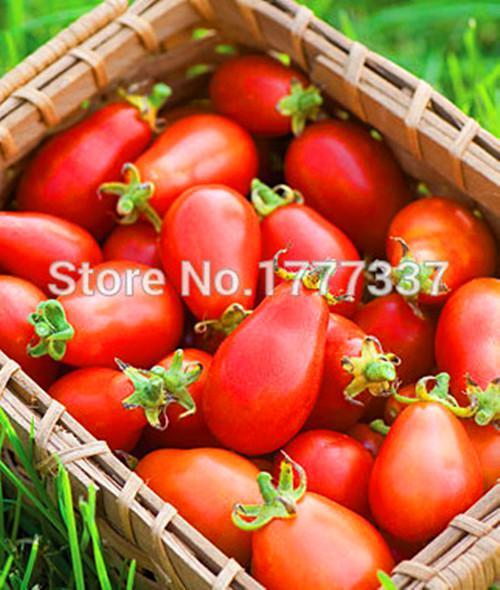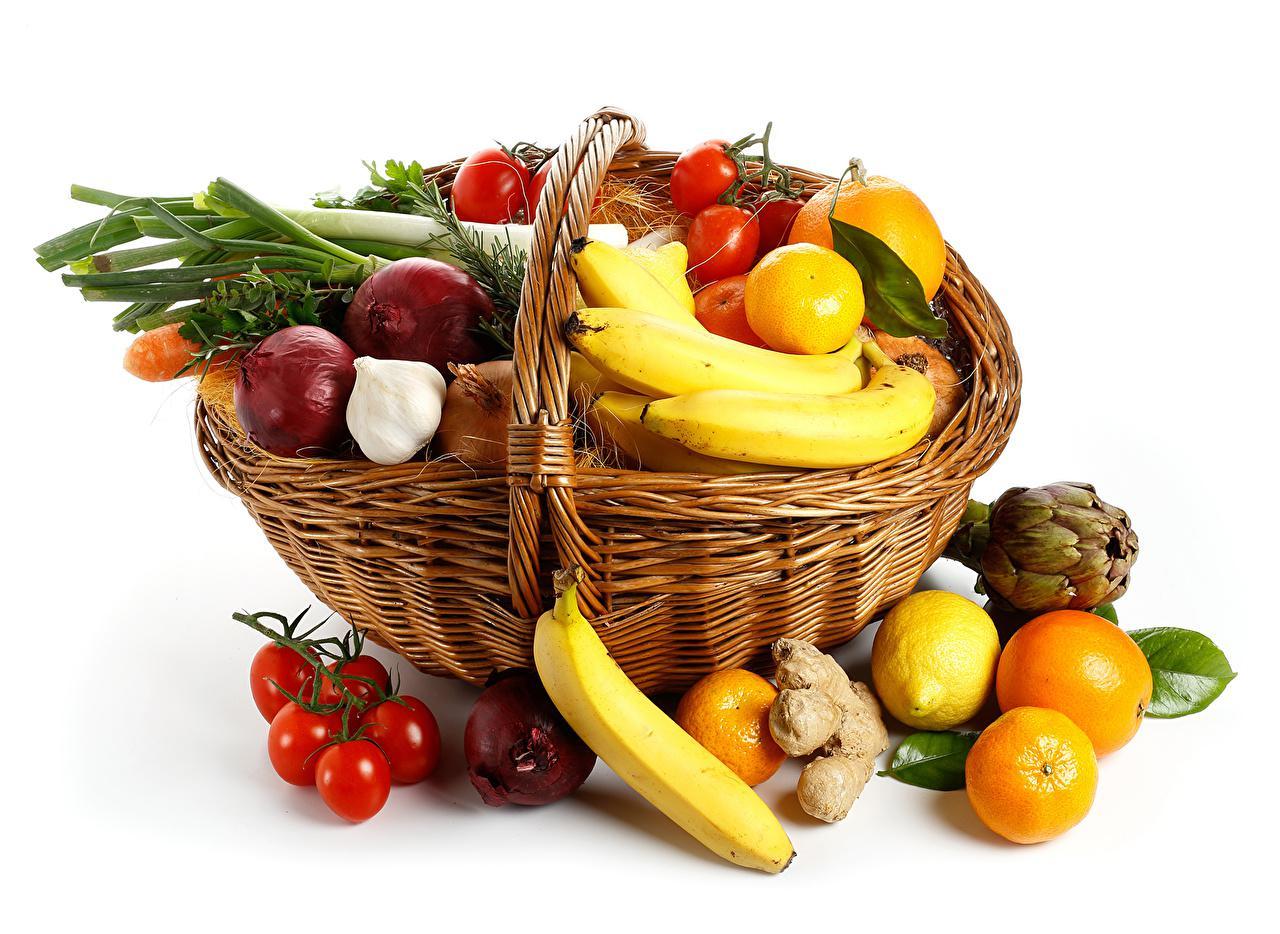The first image is the image on the left, the second image is the image on the right. Assess this claim about the two images: "An image shows at least one banana posed with at least six red tomatoes, and no other produce items.". Correct or not? Answer yes or no. No. The first image is the image on the left, the second image is the image on the right. Analyze the images presented: Is the assertion "In one image, at least one banana is lying flat in an arrangement with at least seven red tomatoes that do not have any stems." valid? Answer yes or no. No. 